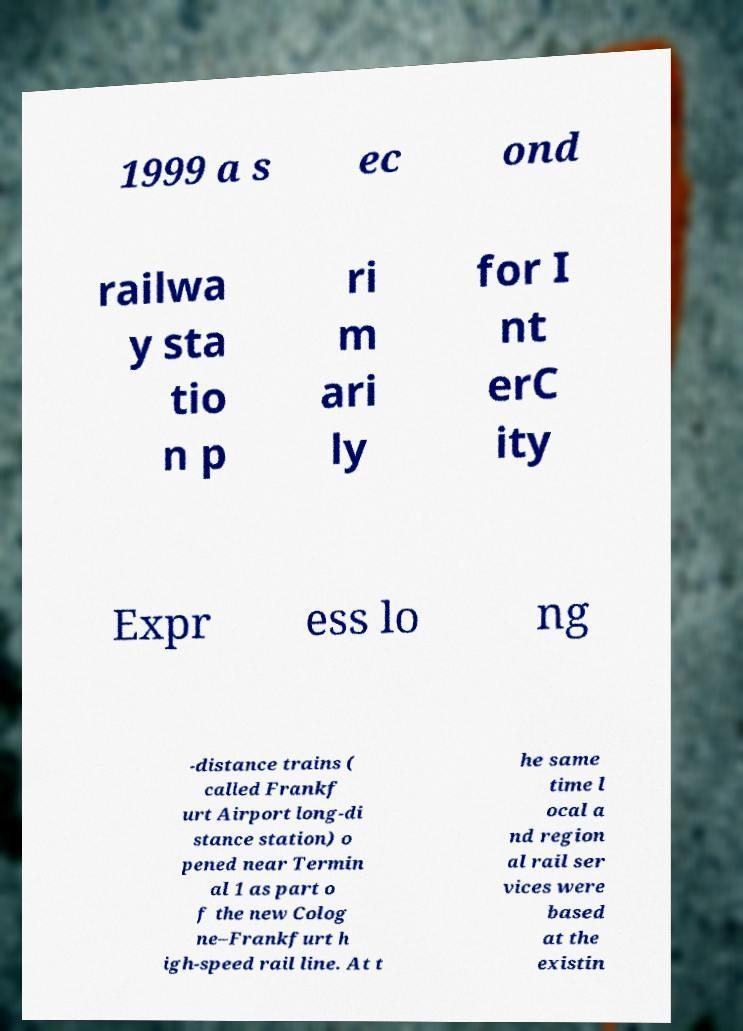Can you accurately transcribe the text from the provided image for me? 1999 a s ec ond railwa y sta tio n p ri m ari ly for I nt erC ity Expr ess lo ng -distance trains ( called Frankf urt Airport long-di stance station) o pened near Termin al 1 as part o f the new Colog ne–Frankfurt h igh-speed rail line. At t he same time l ocal a nd region al rail ser vices were based at the existin 